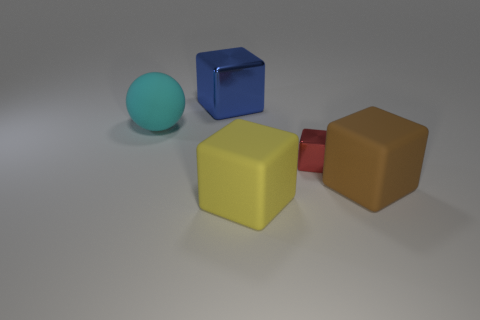Subtract all yellow blocks. How many blocks are left? 3 Add 3 big rubber spheres. How many objects exist? 8 Subtract all brown blocks. How many blocks are left? 3 Subtract all spheres. How many objects are left? 4 Subtract 1 spheres. How many spheres are left? 0 Subtract all red metallic objects. Subtract all small red things. How many objects are left? 3 Add 3 matte objects. How many matte objects are left? 6 Add 4 blue things. How many blue things exist? 5 Subtract 0 cyan cylinders. How many objects are left? 5 Subtract all cyan cubes. Subtract all gray balls. How many cubes are left? 4 